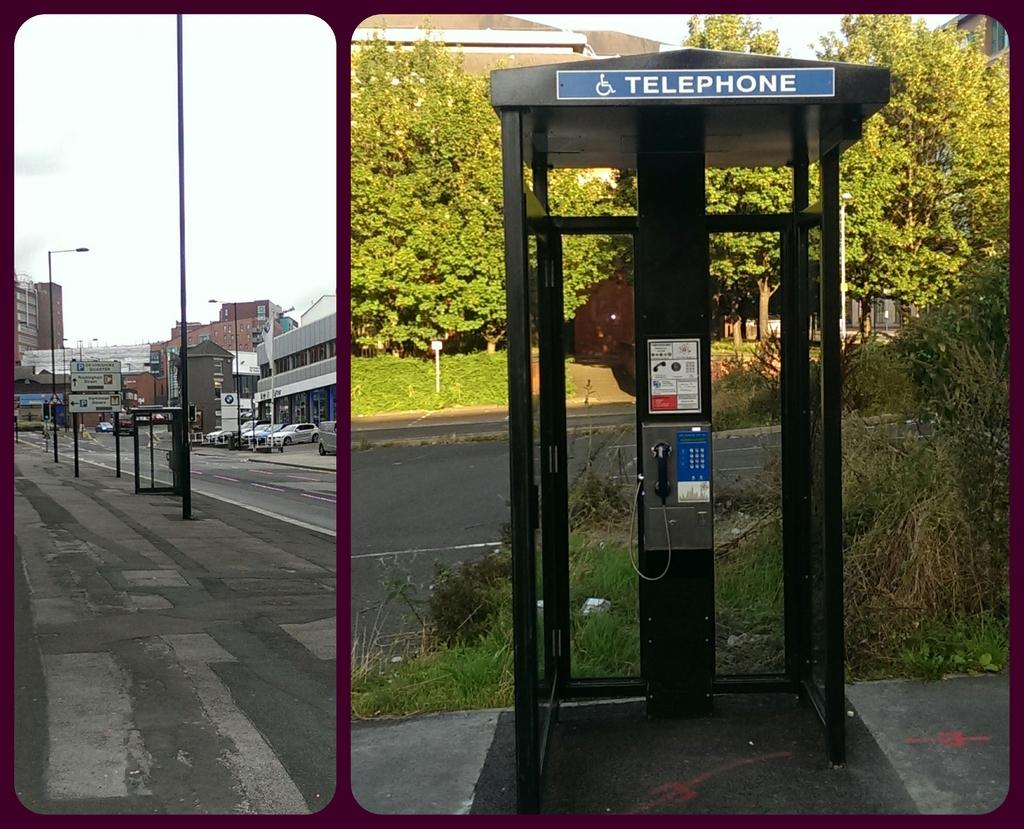<image>
Relay a brief, clear account of the picture shown. a telephone booth sits all alone on the street 